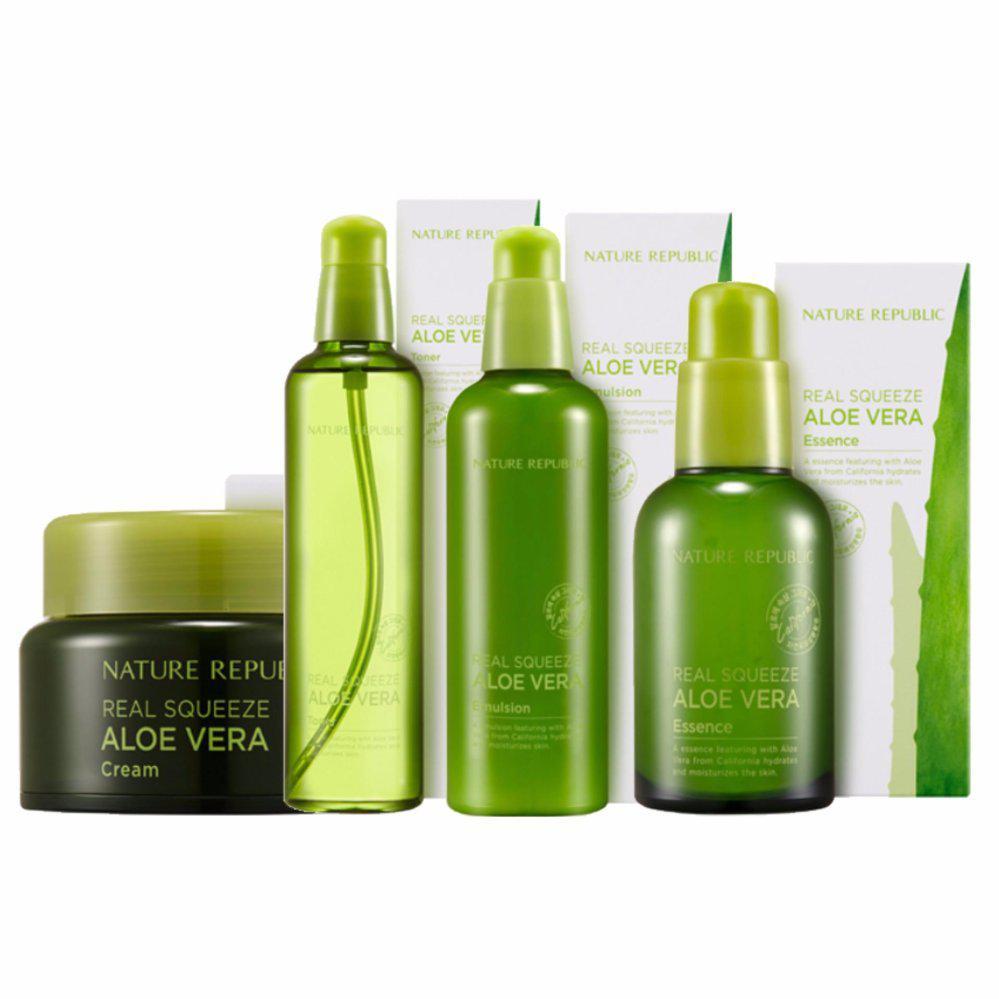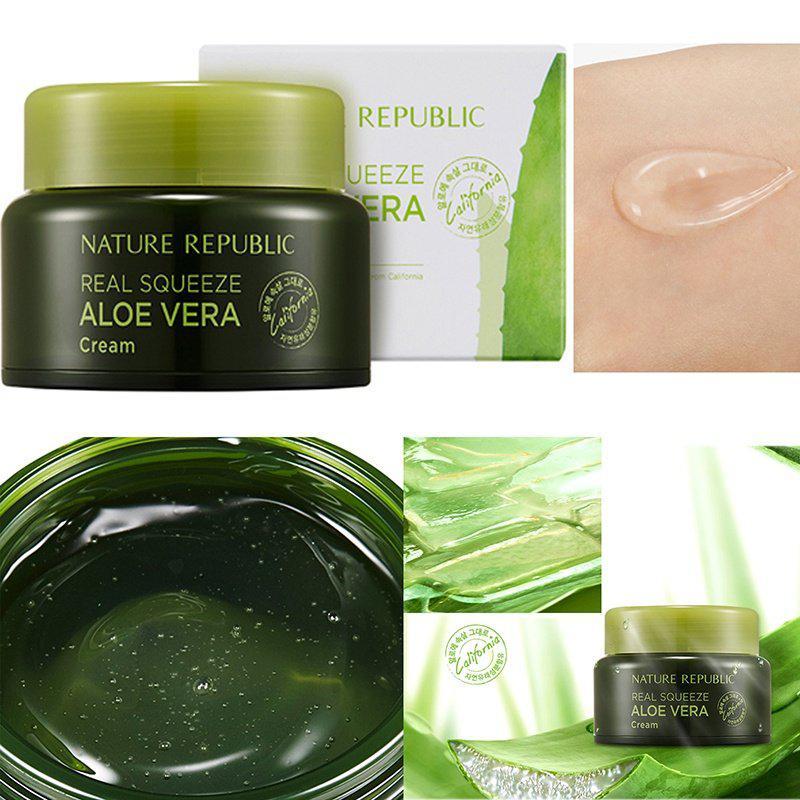The first image is the image on the left, the second image is the image on the right. For the images displayed, is the sentence "There are two products in total in the pair of images." factually correct? Answer yes or no. No. 